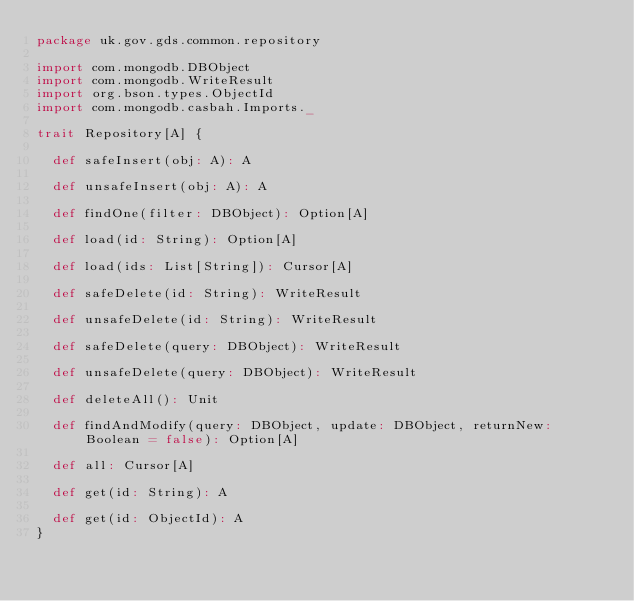Convert code to text. <code><loc_0><loc_0><loc_500><loc_500><_Scala_>package uk.gov.gds.common.repository

import com.mongodb.DBObject
import com.mongodb.WriteResult
import org.bson.types.ObjectId
import com.mongodb.casbah.Imports._

trait Repository[A] {

  def safeInsert(obj: A): A

  def unsafeInsert(obj: A): A

  def findOne(filter: DBObject): Option[A]

  def load(id: String): Option[A]

  def load(ids: List[String]): Cursor[A]

  def safeDelete(id: String): WriteResult

  def unsafeDelete(id: String): WriteResult

  def safeDelete(query: DBObject): WriteResult

  def unsafeDelete(query: DBObject): WriteResult
  
  def deleteAll(): Unit

  def findAndModify(query: DBObject, update: DBObject, returnNew: Boolean = false): Option[A]
  
  def all: Cursor[A]

  def get(id: String): A

  def get(id: ObjectId): A 
}

</code> 